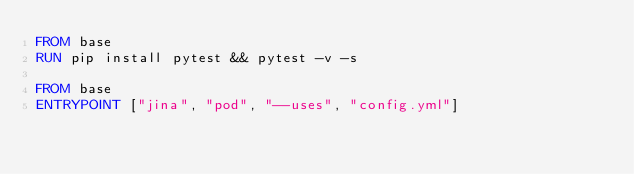<code> <loc_0><loc_0><loc_500><loc_500><_Dockerfile_>FROM base
RUN pip install pytest && pytest -v -s

FROM base
ENTRYPOINT ["jina", "pod", "--uses", "config.yml"]</code> 